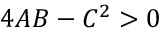Convert formula to latex. <formula><loc_0><loc_0><loc_500><loc_500>4 A B - C ^ { 2 } > 0</formula> 